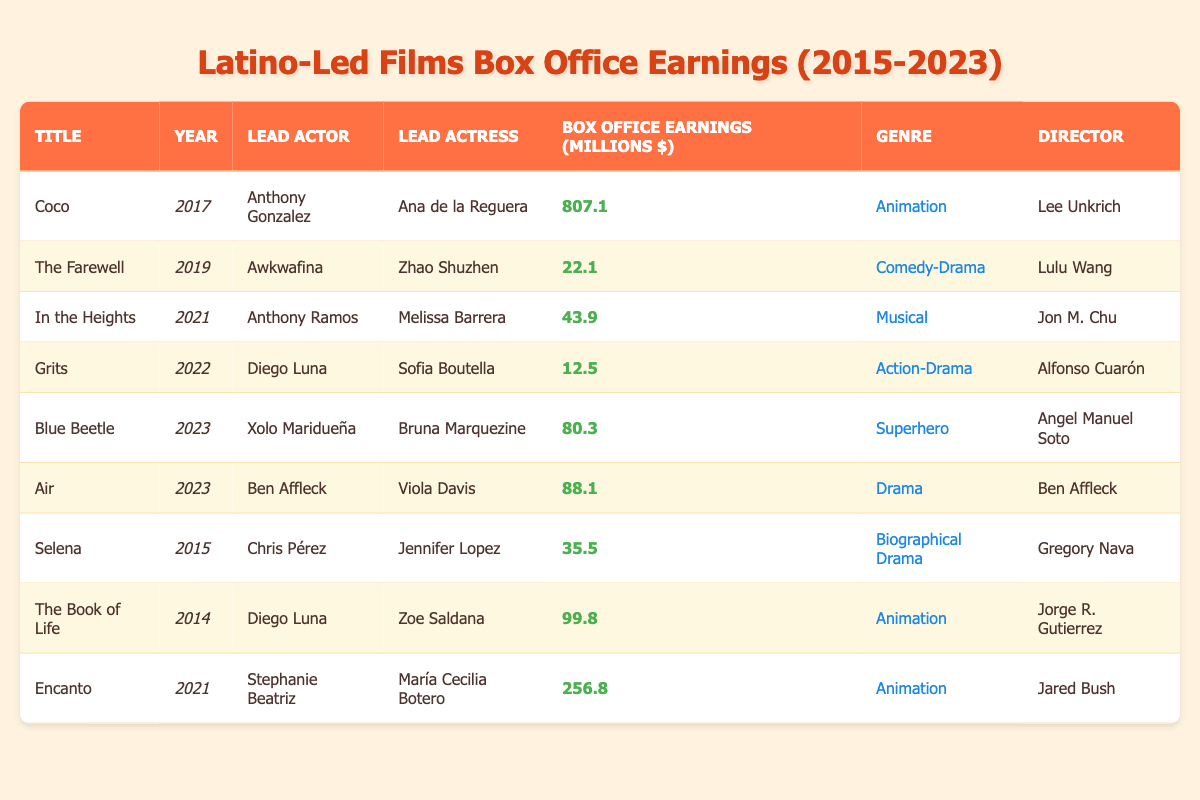What are the box office earnings of "Blue Beetle"? From the table, the box office earnings listed for "Blue Beetle" are 80.3 million dollars.
Answer: 80.3 million dollars Who directed "Coco"? Referring to the table, "Coco" was directed by Lee Unkrich.
Answer: Lee Unkrich Which film had the highest box office earnings among Latino-led films from 2015 to 2023? The highest box office earnings in the table are for "Coco," which made 807.1 million dollars, higher than any other film listed.
Answer: "Coco" What is the total box office earnings of all films in 2021? The films listed for 2021 are "In the Heights" (43.9 million), and "Encanto" (256.8 million). Adding these values gives 43.9 + 256.8 = 300.7 million dollars.
Answer: 300.7 million dollars Is "The Farewell" an animation film? According to the table, "The Farewell" is categorized as a Comedy-Drama, thus it is not an animation film.
Answer: No How many films in the table were released after 2021? The films released after 2021 in the table are "Grits" (2022), "Blue Beetle" (2023), and "Air" (2023), giving a total of 3 films.
Answer: 3 films What is the median box office earnings of all films listed in the table? The box office earnings sorted in ascending order are: 12.5 (Grits), 22.1 (The Farewell), 35.5 (Selena), 43.9 (In the Heights), 80.3 (Blue Beetle), 88.1 (Air), 256.8 (Encanto), and 807.1 (Coco). With 8 films, the median is the average of the 4th and 5th values: (43.9 + 80.3)/2 = 62.1 million dollars.
Answer: 62.1 million dollars Which lead actor featured in the film "Encanto"? The lead actor in "Encanto" is Stephanie Beatriz, as indicated in the table.
Answer: Stephanie Beatriz Which genre had the most films represented in the table? Analyzing the table, Animation appears the most with 4 occurrences (Coco, The Book of Life, Encanto, Grits falls under Action-Drama).
Answer: Animation 